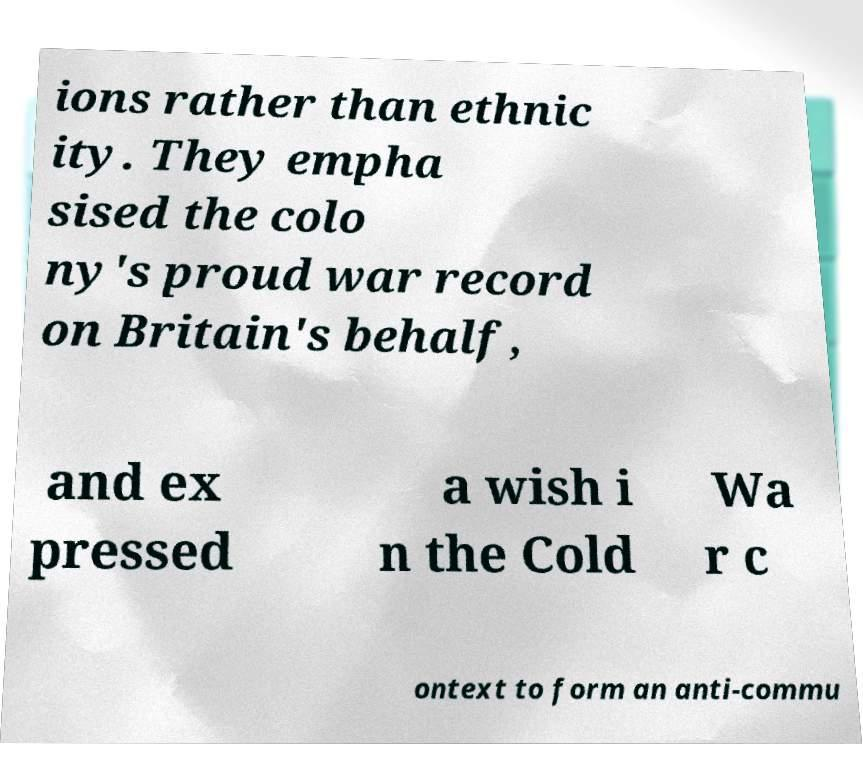Please identify and transcribe the text found in this image. ions rather than ethnic ity. They empha sised the colo ny's proud war record on Britain's behalf, and ex pressed a wish i n the Cold Wa r c ontext to form an anti-commu 